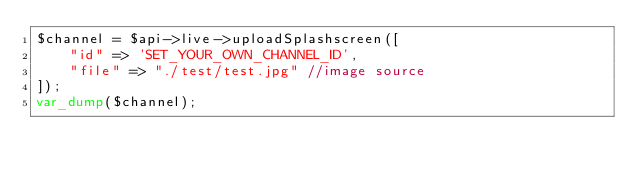<code> <loc_0><loc_0><loc_500><loc_500><_PHP_>$channel = $api->live->uploadSplashscreen([
    "id" => 'SET_YOUR_OWN_CHANNEL_ID',
    "file" => "./test/test.jpg" //image source
]);
var_dump($channel);</code> 